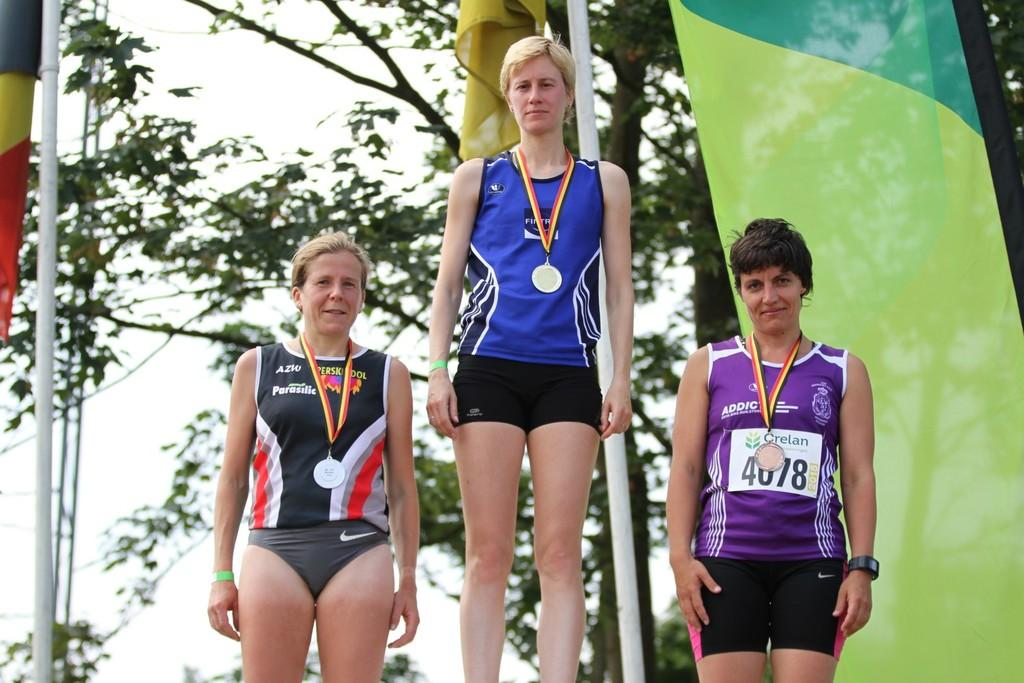<image>
Present a compact description of the photo's key features. three women with gold metals wearing clothing brands by nike and azw 